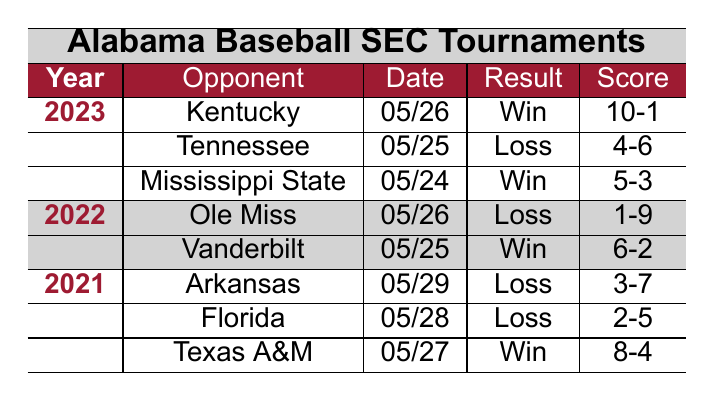What was the result of Alabama's game against Vanderbilt in 2022? The table shows that Alabama played Vanderbilt on May 25, 2022, and the result was a win.
Answer: Win How many games did Alabama play in the SEC tournaments in 2021? According to the table, there are three games listed for the year 2021: against Texas A&M, Florida, and Arkansas. Therefore, Alabama played a total of 3 games in 2021.
Answer: 3 What was Alabama's score against Ole Miss in 2022? Referring to the table, Alabama played against Ole Miss on May 26, 2022, and the score was 1-9, in favor of Ole Miss.
Answer: 1-9 How many wins did Alabama have in the SEC tournaments from 2021 to 2023? In the table, Alabama had wins against Texas A&M (2021), Vanderbilt (2022), and Kentucky (2023), totaling 3 wins overall.
Answer: 3 Which opponent did Alabama lose to by the largest margin in the table? The losses were 2-5 against Florida, 3-7 against Arkansas, 1-9 against Ole Miss, and 4-6 against Tennessee. The largest margin is against Ole Miss, which lost by 8 runs (1-9).
Answer: Ole Miss Did Alabama win any games in 2021? The table indicates that Alabama won 1 game in 2021 against Texas A&M, which confirms they had at least one victory.
Answer: Yes What was the outcome of Alabama's last game in the tournaments listed? The last game listed was against Kentucky on May 26, 2023, and the result was a win.
Answer: Win In which year did Alabama score the highest in a game, according to the table? The highest score was against Kentucky in 2023, where Alabama won with a score of 10-1. Therefore, the highest score was in 2023.
Answer: 2023 How many losses did Alabama incur in the SEC tournaments in 2023? The table shows that Alabama lost 2 games in 2023: against Tennessee and Mississippi State. Hence, Alabama had 2 losses in 2023.
Answer: 2 What was the average score Alabama achieved across the games in 2022? In 2022, Alabama scored 6 against Vanderbilt and 1 against Ole Miss, making a total of 7 runs across 2 games. Therefore, the average score is 7/2 = 3.5.
Answer: 3.5 